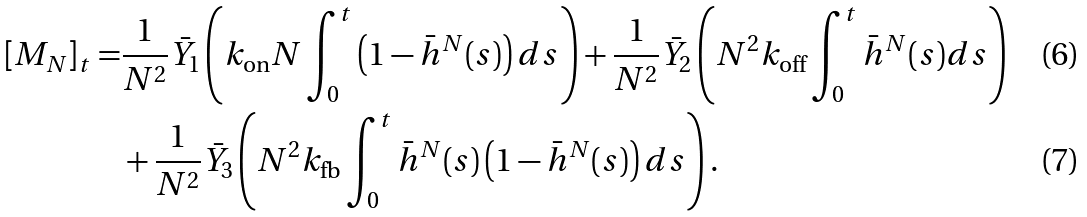Convert formula to latex. <formula><loc_0><loc_0><loc_500><loc_500>[ M _ { N } ] _ { t } = & \frac { 1 } { N ^ { 2 } } \bar { Y } _ { 1 } \left ( k _ { \text {on} } N \int _ { 0 } ^ { t } \left ( 1 - \bar { h } ^ { N } ( s ) \right ) d s \right ) + \frac { 1 } { N ^ { 2 } } \bar { Y } _ { 2 } \left ( N ^ { 2 } k _ { \text {off} } \int _ { 0 } ^ { t } \bar { h } ^ { N } ( s ) d s \right ) \\ & + \frac { 1 } { N ^ { 2 } } \bar { Y } _ { 3 } \left ( N ^ { 2 } k _ { \text {fb} } \int _ { 0 } ^ { t } \bar { h } ^ { N } ( s ) \left ( 1 - \bar { h } ^ { N } ( s ) \right ) d s \right ) .</formula> 